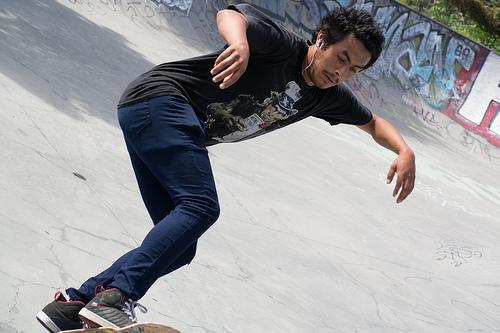Question: what is this guy doing?
Choices:
A. Skateboarding.
B. Skiing.
C. Flying.
D. Swimming.
Answer with the letter. Answer: A Question: what color shirt is this guy wearing?
Choices:
A. Blue.
B. Green.
C. Orange.
D. Black.
Answer with the letter. Answer: D Question: why is he holding his hands like that?
Choices:
A. For fun.
B. To express himself.
C. He's signalling to his friends.
D. For balance.
Answer with the letter. Answer: D 